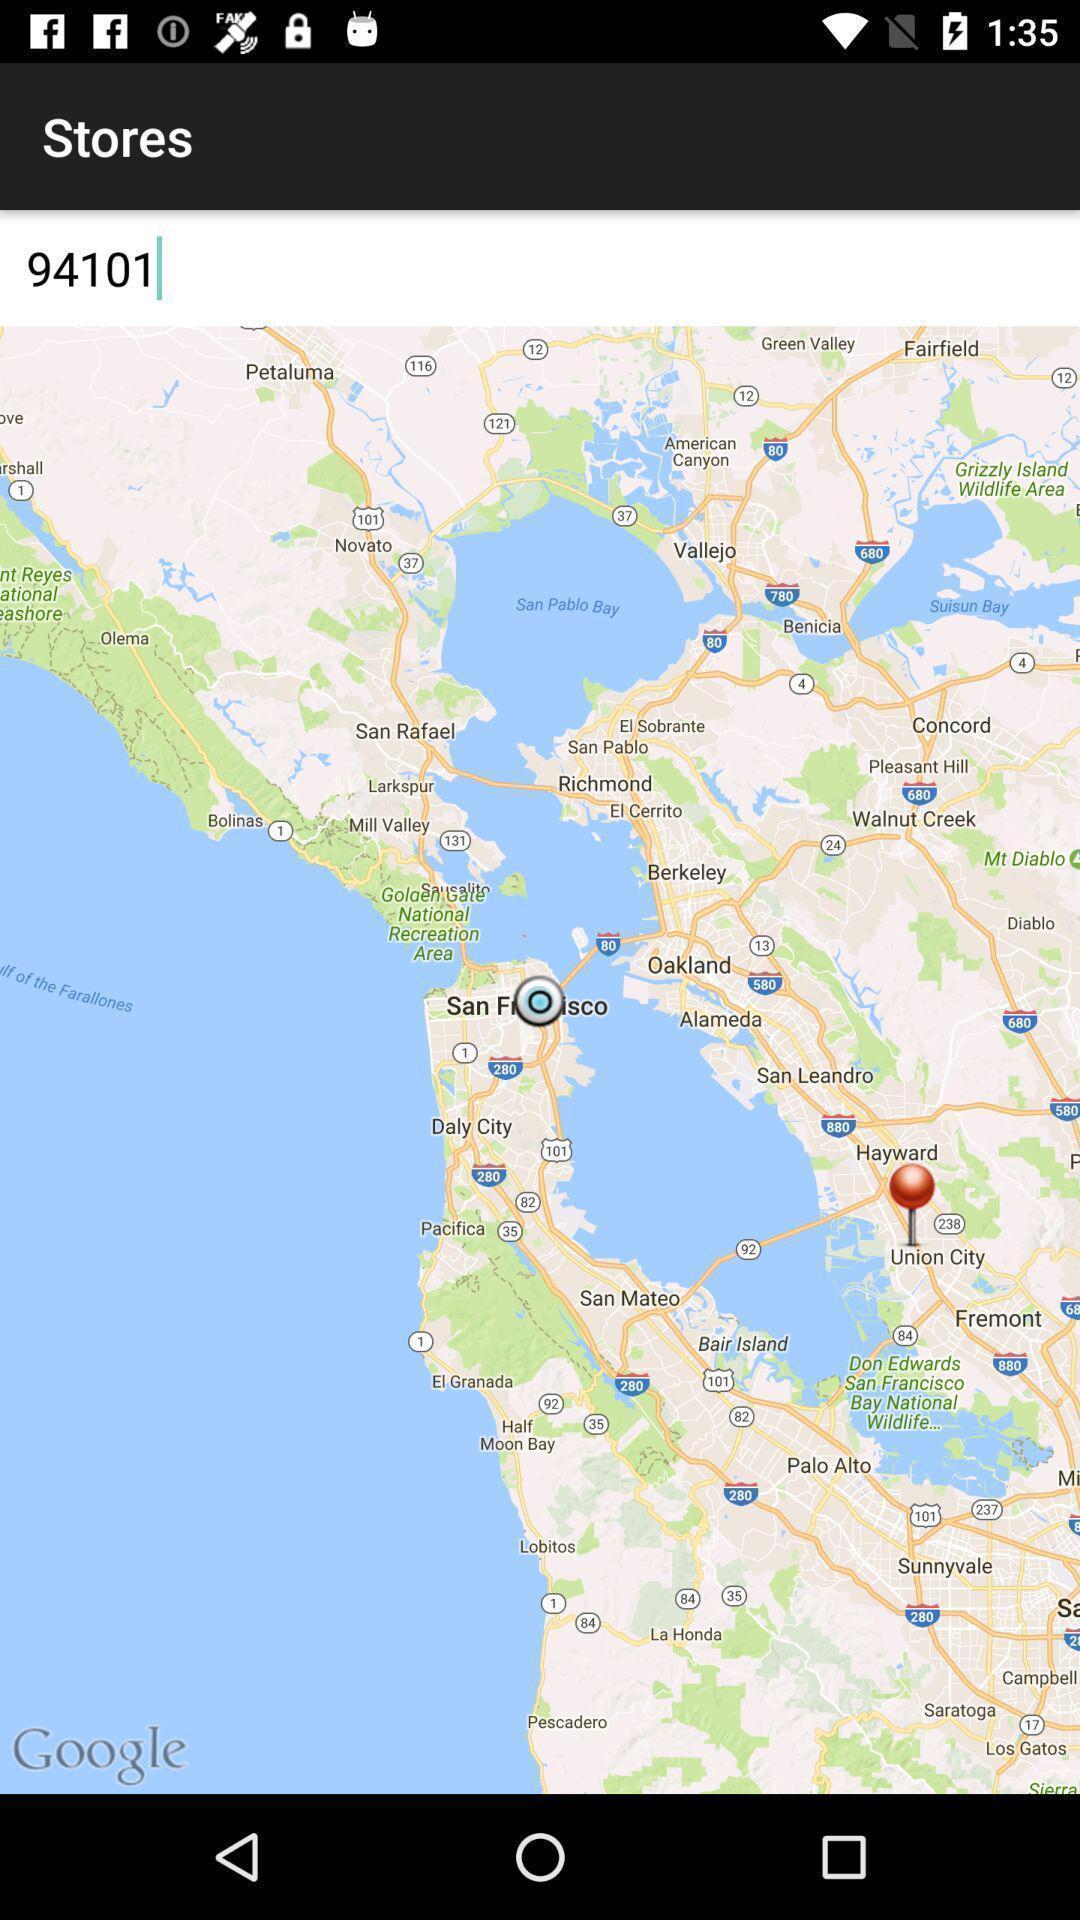What details can you identify in this image? Page for search stores. 